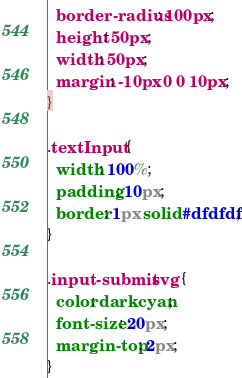Convert code to text. <code><loc_0><loc_0><loc_500><loc_500><_CSS_>  border-radius: 100px;
  height: 50px;
  width: 50px;
  margin: -10px 0 0 10px;
}

.textInput {
  width: 100%;
  padding: 10px;
  border: 1px solid #dfdfdf;
}

.input-submit svg {
  color: darkcyan;
  font-size: 20px;
  margin-top: 2px;
}
</code> 